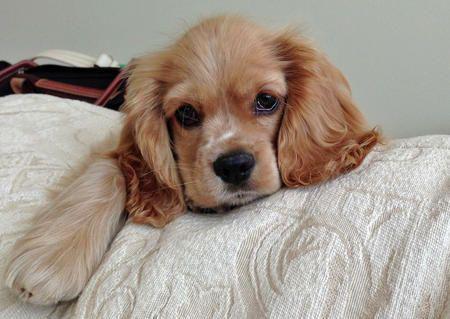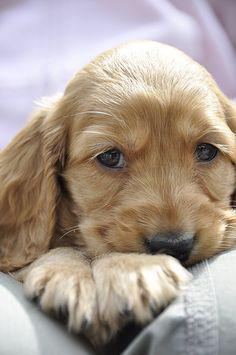The first image is the image on the left, the second image is the image on the right. Considering the images on both sides, is "The dog in the image on the right is sitting." valid? Answer yes or no. No. 